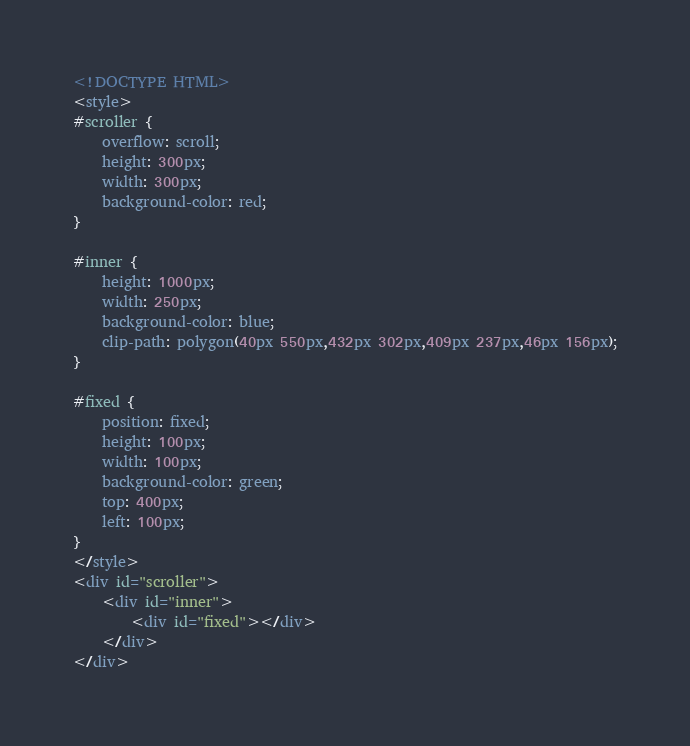<code> <loc_0><loc_0><loc_500><loc_500><_HTML_><!DOCTYPE HTML>
<style>
#scroller {
    overflow: scroll;
    height: 300px;
    width: 300px;
    background-color: red;
}

#inner {
    height: 1000px;
    width: 250px;
    background-color: blue;
    clip-path: polygon(40px 550px,432px 302px,409px 237px,46px 156px);
}

#fixed {
    position: fixed;
    height: 100px;
    width: 100px;
    background-color: green;
    top: 400px;
    left: 100px;
}
</style>
<div id="scroller">
    <div id="inner">
        <div id="fixed"></div>
    </div>
</div>
</code> 